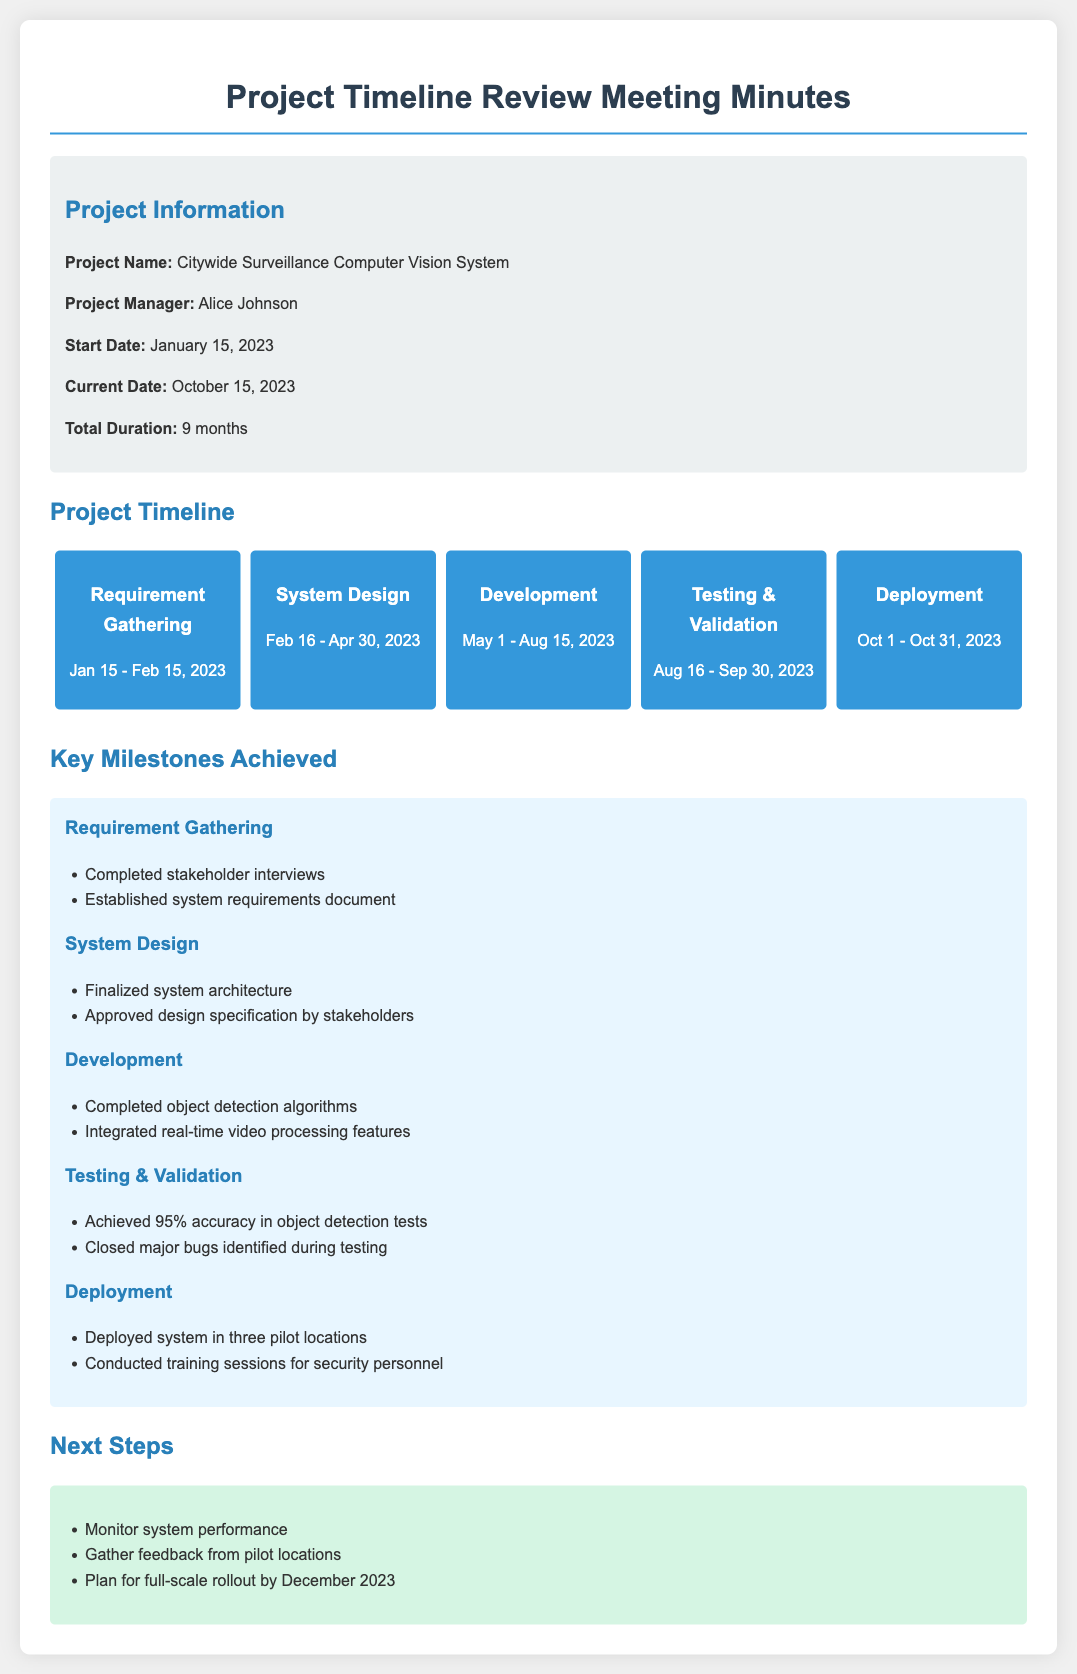what is the project name? The project name is mentioned in the project information section, which is the Citywide Surveillance Computer Vision System.
Answer: Citywide Surveillance Computer Vision System who is the project manager? The project manager's name is provided in the project information section.
Answer: Alice Johnson what is the start date of the project? The start date is outlined in the project information section, dated January 15, 2023.
Answer: January 15, 2023 what is the current date mentioned in the document? The current date can be found in the project information section as October 15, 2023.
Answer: October 15, 2023 how long is the total duration of the project? The total duration is specified in the project information section, which is 9 months.
Answer: 9 months what are two key milestones achieved in the Development phase? The milestones can be found in the key milestones achieved section for Development, specifically mentioning completed object detection algorithms and integrated real-time video processing features.
Answer: Completed object detection algorithms, Integrated real-time video processing features what is the accuracy achieved during Testing & Validation? The accuracy is mentioned in the Testing & Validation section under key milestones, which is 95%.
Answer: 95% what was a key milestone from the Requirement Gathering phase? Key milestones are listed under each phase; one mentioned in Requirement Gathering is completed stakeholder interviews.
Answer: Completed stakeholder interviews what is one next step planned after deployment? The next steps can be found in the next steps section, which mentions monitoring system performance.
Answer: Monitor system performance 